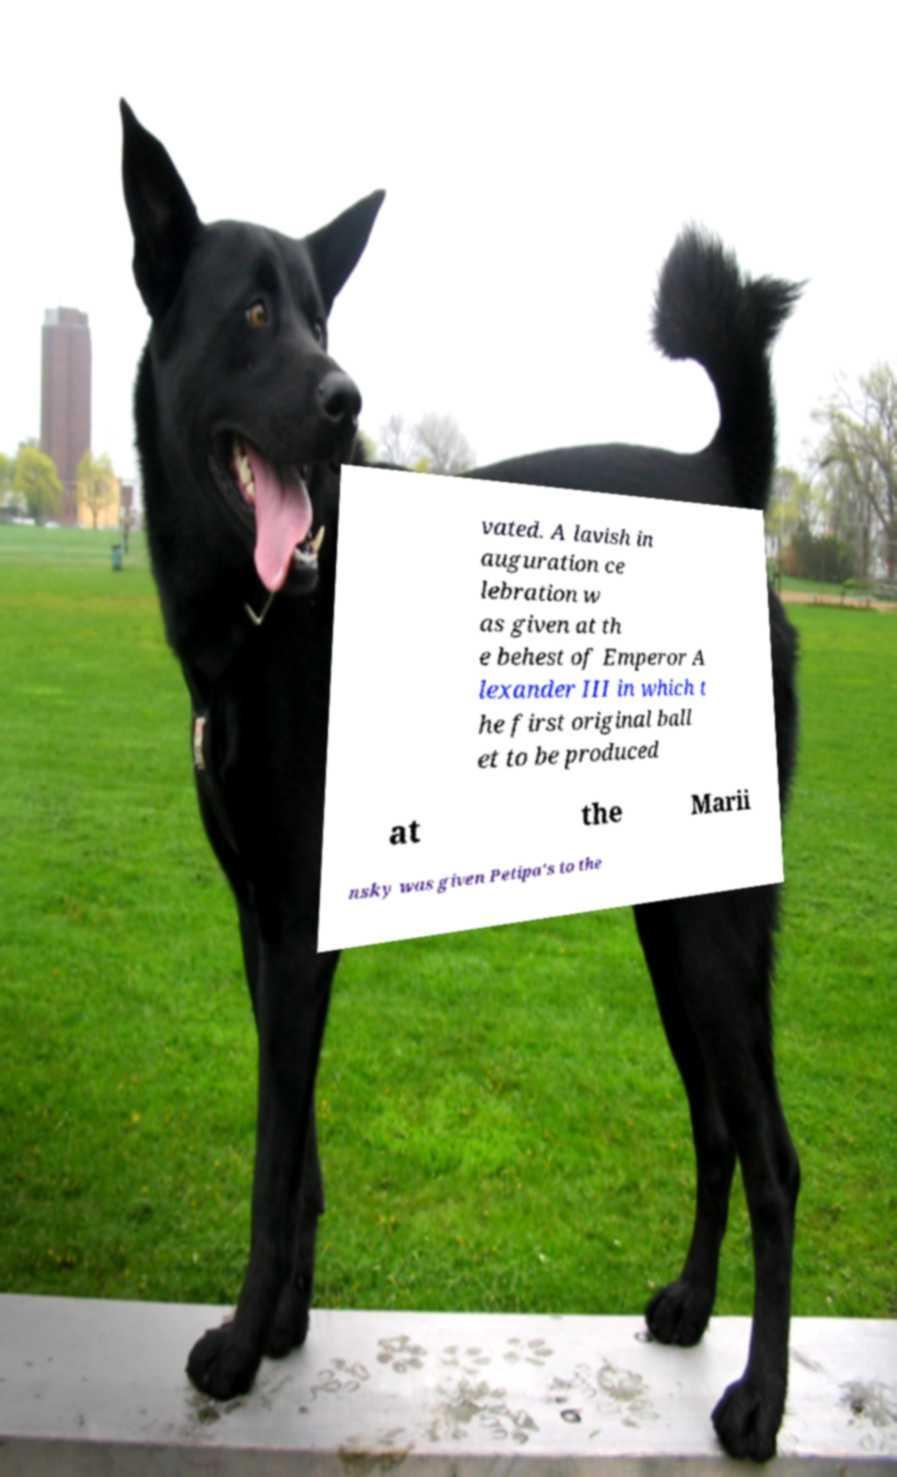Could you extract and type out the text from this image? vated. A lavish in auguration ce lebration w as given at th e behest of Emperor A lexander III in which t he first original ball et to be produced at the Marii nsky was given Petipa's to the 